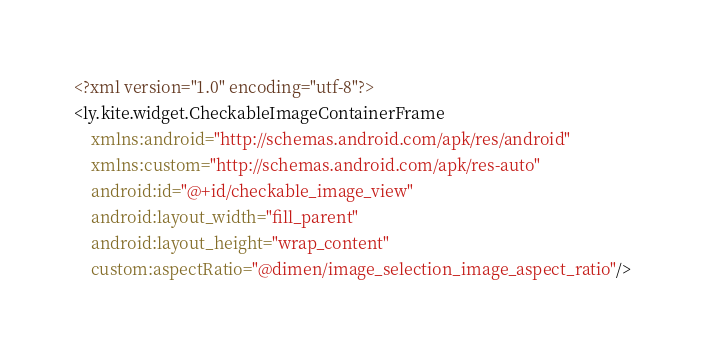Convert code to text. <code><loc_0><loc_0><loc_500><loc_500><_XML_><?xml version="1.0" encoding="utf-8"?>
<ly.kite.widget.CheckableImageContainerFrame
    xmlns:android="http://schemas.android.com/apk/res/android"
    xmlns:custom="http://schemas.android.com/apk/res-auto"
    android:id="@+id/checkable_image_view"
    android:layout_width="fill_parent"
    android:layout_height="wrap_content"
    custom:aspectRatio="@dimen/image_selection_image_aspect_ratio"/>
</code> 